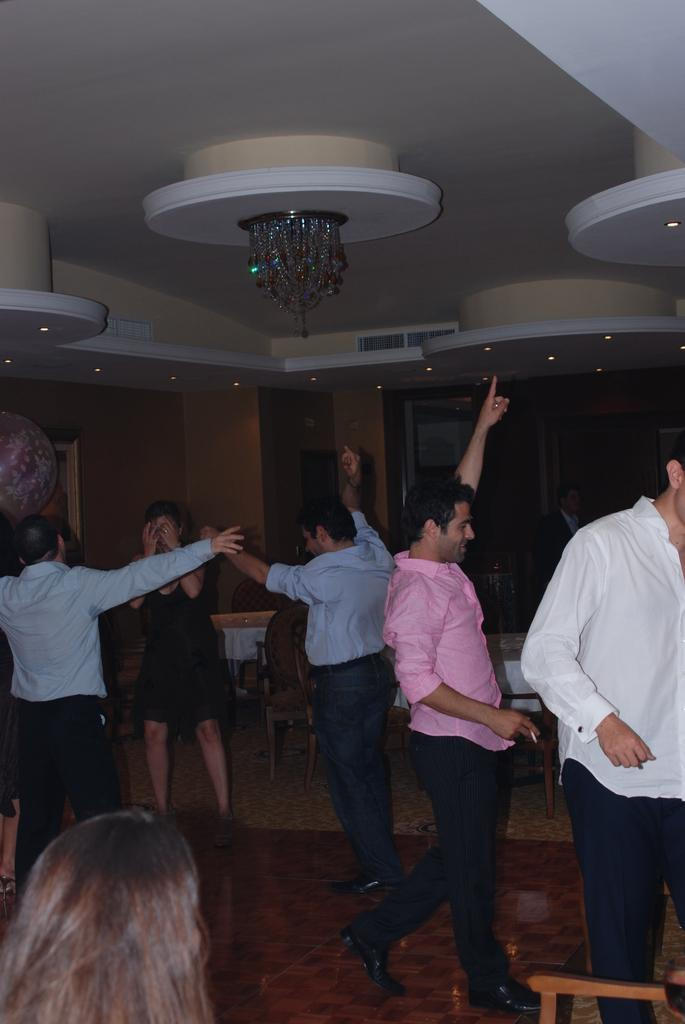What are the people in the image doing? The people in the image are performing dance. What type of furniture can be seen in the image? There are chairs and tables in the image. What is the background of the image made of? There is a wall in the image. What part of the room is visible in the image? The ceiling is visible in the image. What is providing illumination in the image? There are lights visible in the image. Can you see any cracks on the wall in the image? There is no mention of any cracks on the wall in the image. Are the people in the image kissing each other? There is no indication of any kissing in the image; the people are performing dance. What type of room is depicted in the image? The room type cannot be determined from the image alone, as there is no specific context provided. 